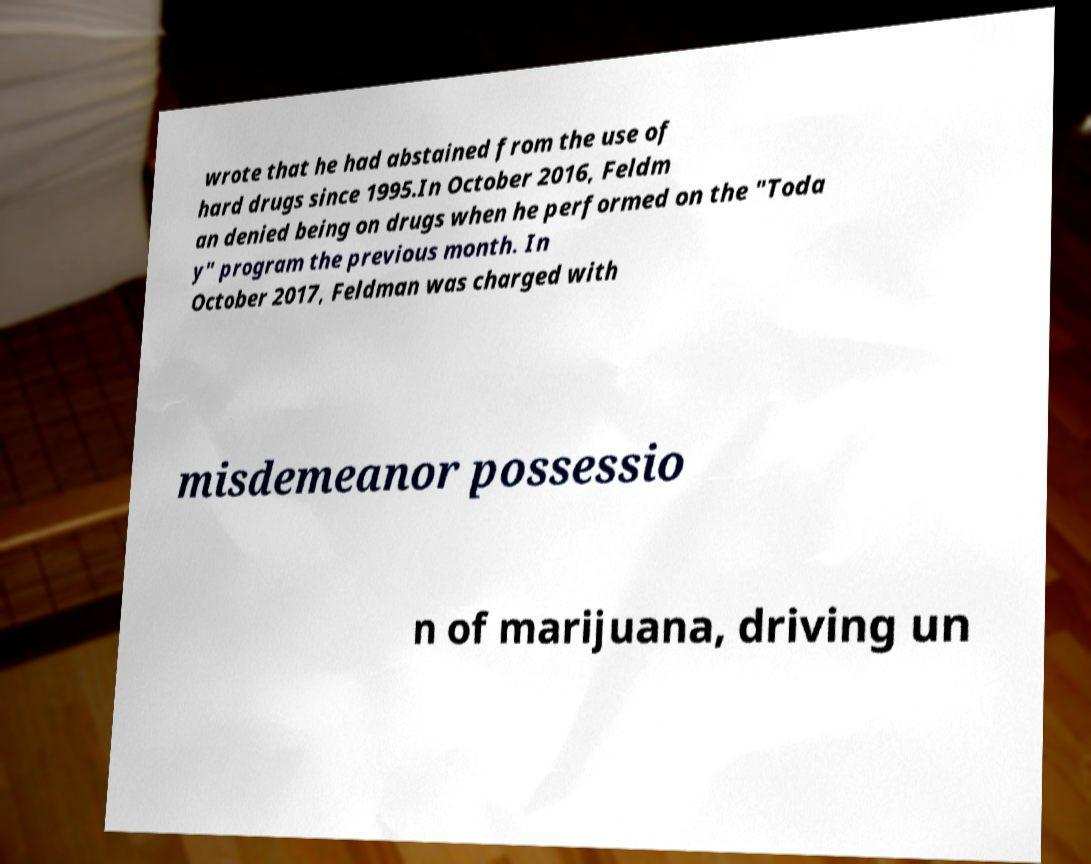Can you accurately transcribe the text from the provided image for me? wrote that he had abstained from the use of hard drugs since 1995.In October 2016, Feldm an denied being on drugs when he performed on the "Toda y" program the previous month. In October 2017, Feldman was charged with misdemeanor possessio n of marijuana, driving un 